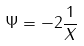<formula> <loc_0><loc_0><loc_500><loc_500>\Psi = - 2 \frac { 1 } { X }</formula> 